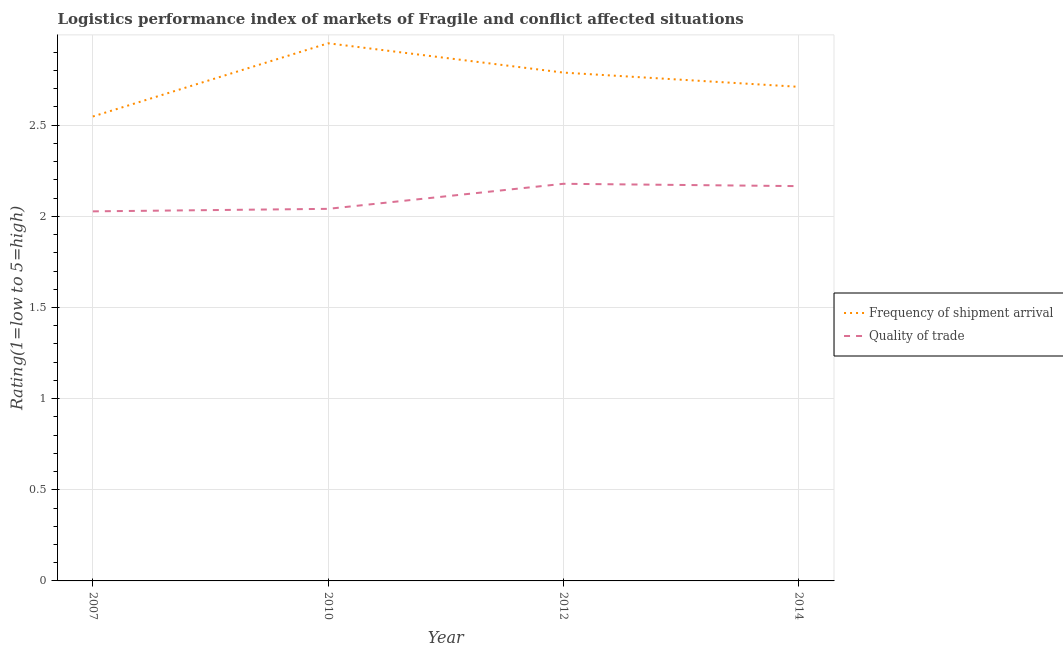Does the line corresponding to lpi of frequency of shipment arrival intersect with the line corresponding to lpi quality of trade?
Keep it short and to the point. No. What is the lpi quality of trade in 2014?
Your response must be concise. 2.17. Across all years, what is the maximum lpi quality of trade?
Make the answer very short. 2.18. Across all years, what is the minimum lpi of frequency of shipment arrival?
Keep it short and to the point. 2.55. In which year was the lpi quality of trade maximum?
Give a very brief answer. 2012. In which year was the lpi of frequency of shipment arrival minimum?
Ensure brevity in your answer.  2007. What is the total lpi quality of trade in the graph?
Give a very brief answer. 8.41. What is the difference between the lpi of frequency of shipment arrival in 2010 and that in 2012?
Provide a succinct answer. 0.16. What is the difference between the lpi of frequency of shipment arrival in 2007 and the lpi quality of trade in 2010?
Offer a terse response. 0.51. What is the average lpi quality of trade per year?
Provide a short and direct response. 2.1. In the year 2012, what is the difference between the lpi quality of trade and lpi of frequency of shipment arrival?
Ensure brevity in your answer.  -0.61. What is the ratio of the lpi quality of trade in 2007 to that in 2012?
Give a very brief answer. 0.93. Is the lpi of frequency of shipment arrival in 2010 less than that in 2014?
Your answer should be very brief. No. Is the difference between the lpi quality of trade in 2007 and 2010 greater than the difference between the lpi of frequency of shipment arrival in 2007 and 2010?
Your answer should be very brief. Yes. What is the difference between the highest and the second highest lpi quality of trade?
Keep it short and to the point. 0.01. What is the difference between the highest and the lowest lpi quality of trade?
Provide a short and direct response. 0.15. How many lines are there?
Provide a short and direct response. 2. How many years are there in the graph?
Make the answer very short. 4. What is the difference between two consecutive major ticks on the Y-axis?
Make the answer very short. 0.5. Are the values on the major ticks of Y-axis written in scientific E-notation?
Your answer should be very brief. No. Does the graph contain any zero values?
Offer a very short reply. No. How many legend labels are there?
Your answer should be very brief. 2. How are the legend labels stacked?
Your answer should be very brief. Vertical. What is the title of the graph?
Give a very brief answer. Logistics performance index of markets of Fragile and conflict affected situations. What is the label or title of the Y-axis?
Ensure brevity in your answer.  Rating(1=low to 5=high). What is the Rating(1=low to 5=high) in Frequency of shipment arrival in 2007?
Your answer should be very brief. 2.55. What is the Rating(1=low to 5=high) in Quality of trade in 2007?
Provide a succinct answer. 2.03. What is the Rating(1=low to 5=high) of Frequency of shipment arrival in 2010?
Make the answer very short. 2.95. What is the Rating(1=low to 5=high) in Quality of trade in 2010?
Provide a succinct answer. 2.04. What is the Rating(1=low to 5=high) in Frequency of shipment arrival in 2012?
Give a very brief answer. 2.79. What is the Rating(1=low to 5=high) of Quality of trade in 2012?
Give a very brief answer. 2.18. What is the Rating(1=low to 5=high) in Frequency of shipment arrival in 2014?
Offer a terse response. 2.71. What is the Rating(1=low to 5=high) of Quality of trade in 2014?
Offer a terse response. 2.17. Across all years, what is the maximum Rating(1=low to 5=high) in Frequency of shipment arrival?
Your answer should be very brief. 2.95. Across all years, what is the maximum Rating(1=low to 5=high) of Quality of trade?
Provide a short and direct response. 2.18. Across all years, what is the minimum Rating(1=low to 5=high) in Frequency of shipment arrival?
Ensure brevity in your answer.  2.55. Across all years, what is the minimum Rating(1=low to 5=high) in Quality of trade?
Make the answer very short. 2.03. What is the total Rating(1=low to 5=high) in Frequency of shipment arrival in the graph?
Offer a very short reply. 11. What is the total Rating(1=low to 5=high) of Quality of trade in the graph?
Give a very brief answer. 8.41. What is the difference between the Rating(1=low to 5=high) of Frequency of shipment arrival in 2007 and that in 2010?
Offer a very short reply. -0.4. What is the difference between the Rating(1=low to 5=high) of Quality of trade in 2007 and that in 2010?
Make the answer very short. -0.01. What is the difference between the Rating(1=low to 5=high) of Frequency of shipment arrival in 2007 and that in 2012?
Make the answer very short. -0.24. What is the difference between the Rating(1=low to 5=high) in Quality of trade in 2007 and that in 2012?
Offer a very short reply. -0.15. What is the difference between the Rating(1=low to 5=high) of Frequency of shipment arrival in 2007 and that in 2014?
Your response must be concise. -0.16. What is the difference between the Rating(1=low to 5=high) of Quality of trade in 2007 and that in 2014?
Make the answer very short. -0.14. What is the difference between the Rating(1=low to 5=high) in Frequency of shipment arrival in 2010 and that in 2012?
Make the answer very short. 0.16. What is the difference between the Rating(1=low to 5=high) in Quality of trade in 2010 and that in 2012?
Ensure brevity in your answer.  -0.14. What is the difference between the Rating(1=low to 5=high) in Frequency of shipment arrival in 2010 and that in 2014?
Keep it short and to the point. 0.24. What is the difference between the Rating(1=low to 5=high) in Quality of trade in 2010 and that in 2014?
Keep it short and to the point. -0.12. What is the difference between the Rating(1=low to 5=high) of Frequency of shipment arrival in 2012 and that in 2014?
Make the answer very short. 0.08. What is the difference between the Rating(1=low to 5=high) in Quality of trade in 2012 and that in 2014?
Provide a short and direct response. 0.01. What is the difference between the Rating(1=low to 5=high) in Frequency of shipment arrival in 2007 and the Rating(1=low to 5=high) in Quality of trade in 2010?
Offer a terse response. 0.51. What is the difference between the Rating(1=low to 5=high) in Frequency of shipment arrival in 2007 and the Rating(1=low to 5=high) in Quality of trade in 2012?
Your answer should be very brief. 0.37. What is the difference between the Rating(1=low to 5=high) in Frequency of shipment arrival in 2007 and the Rating(1=low to 5=high) in Quality of trade in 2014?
Give a very brief answer. 0.38. What is the difference between the Rating(1=low to 5=high) in Frequency of shipment arrival in 2010 and the Rating(1=low to 5=high) in Quality of trade in 2012?
Your response must be concise. 0.77. What is the difference between the Rating(1=low to 5=high) in Frequency of shipment arrival in 2010 and the Rating(1=low to 5=high) in Quality of trade in 2014?
Make the answer very short. 0.78. What is the difference between the Rating(1=low to 5=high) of Frequency of shipment arrival in 2012 and the Rating(1=low to 5=high) of Quality of trade in 2014?
Provide a succinct answer. 0.62. What is the average Rating(1=low to 5=high) in Frequency of shipment arrival per year?
Offer a very short reply. 2.75. What is the average Rating(1=low to 5=high) in Quality of trade per year?
Make the answer very short. 2.1. In the year 2007, what is the difference between the Rating(1=low to 5=high) of Frequency of shipment arrival and Rating(1=low to 5=high) of Quality of trade?
Give a very brief answer. 0.52. In the year 2010, what is the difference between the Rating(1=low to 5=high) in Frequency of shipment arrival and Rating(1=low to 5=high) in Quality of trade?
Your answer should be very brief. 0.91. In the year 2012, what is the difference between the Rating(1=low to 5=high) of Frequency of shipment arrival and Rating(1=low to 5=high) of Quality of trade?
Your answer should be compact. 0.61. In the year 2014, what is the difference between the Rating(1=low to 5=high) in Frequency of shipment arrival and Rating(1=low to 5=high) in Quality of trade?
Provide a succinct answer. 0.54. What is the ratio of the Rating(1=low to 5=high) in Frequency of shipment arrival in 2007 to that in 2010?
Your answer should be compact. 0.86. What is the ratio of the Rating(1=low to 5=high) of Quality of trade in 2007 to that in 2010?
Offer a terse response. 0.99. What is the ratio of the Rating(1=low to 5=high) in Frequency of shipment arrival in 2007 to that in 2012?
Offer a very short reply. 0.91. What is the ratio of the Rating(1=low to 5=high) in Quality of trade in 2007 to that in 2012?
Make the answer very short. 0.93. What is the ratio of the Rating(1=low to 5=high) of Frequency of shipment arrival in 2007 to that in 2014?
Provide a succinct answer. 0.94. What is the ratio of the Rating(1=low to 5=high) in Quality of trade in 2007 to that in 2014?
Your answer should be compact. 0.94. What is the ratio of the Rating(1=low to 5=high) in Frequency of shipment arrival in 2010 to that in 2012?
Make the answer very short. 1.06. What is the ratio of the Rating(1=low to 5=high) in Quality of trade in 2010 to that in 2012?
Offer a very short reply. 0.94. What is the ratio of the Rating(1=low to 5=high) in Frequency of shipment arrival in 2010 to that in 2014?
Your answer should be very brief. 1.09. What is the ratio of the Rating(1=low to 5=high) of Quality of trade in 2010 to that in 2014?
Ensure brevity in your answer.  0.94. What is the ratio of the Rating(1=low to 5=high) in Frequency of shipment arrival in 2012 to that in 2014?
Provide a short and direct response. 1.03. What is the ratio of the Rating(1=low to 5=high) of Quality of trade in 2012 to that in 2014?
Your answer should be very brief. 1.01. What is the difference between the highest and the second highest Rating(1=low to 5=high) in Frequency of shipment arrival?
Your answer should be compact. 0.16. What is the difference between the highest and the second highest Rating(1=low to 5=high) in Quality of trade?
Your answer should be compact. 0.01. What is the difference between the highest and the lowest Rating(1=low to 5=high) of Frequency of shipment arrival?
Offer a terse response. 0.4. What is the difference between the highest and the lowest Rating(1=low to 5=high) of Quality of trade?
Offer a very short reply. 0.15. 